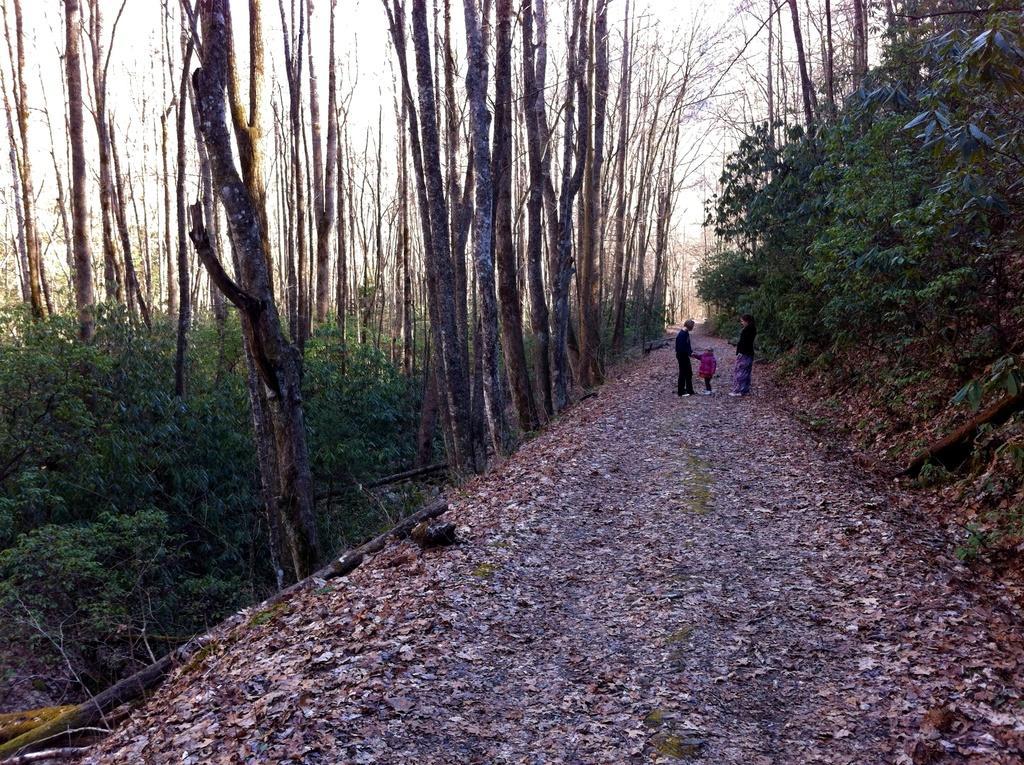In one or two sentences, can you explain what this image depicts? There is a road. On the road there are three people. On the sides of the road there are trees. Also there are dried leaves on the road. In the background there is sky. 